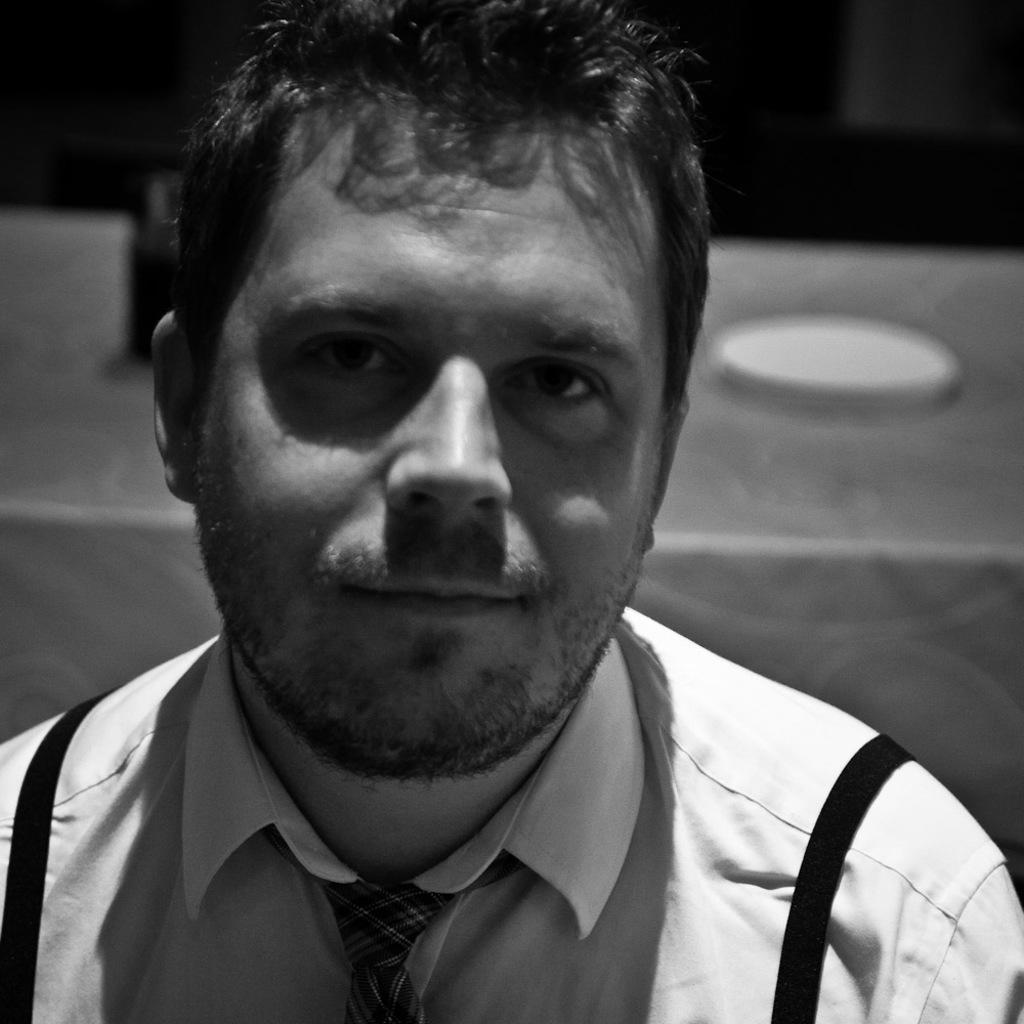In one or two sentences, can you explain what this image depicts? In this picture we can see a man wore a tie and smiling and in the background it is dark. 